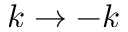<formula> <loc_0><loc_0><loc_500><loc_500>k \rightarrow - k</formula> 